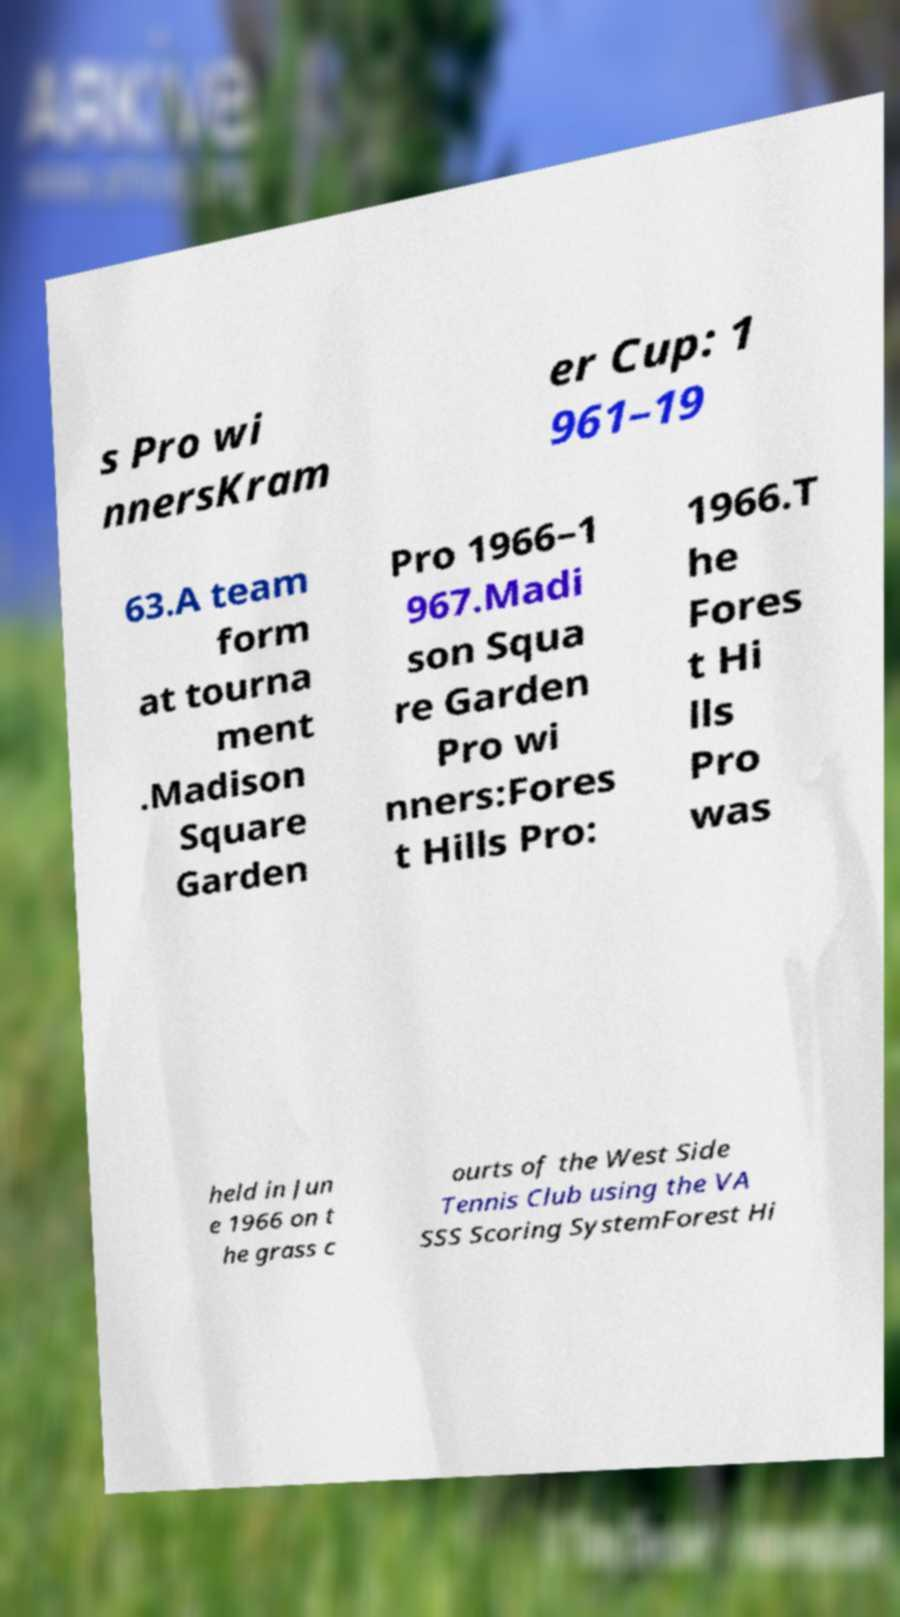For documentation purposes, I need the text within this image transcribed. Could you provide that? s Pro wi nnersKram er Cup: 1 961–19 63.A team form at tourna ment .Madison Square Garden Pro 1966–1 967.Madi son Squa re Garden Pro wi nners:Fores t Hills Pro: 1966.T he Fores t Hi lls Pro was held in Jun e 1966 on t he grass c ourts of the West Side Tennis Club using the VA SSS Scoring SystemForest Hi 